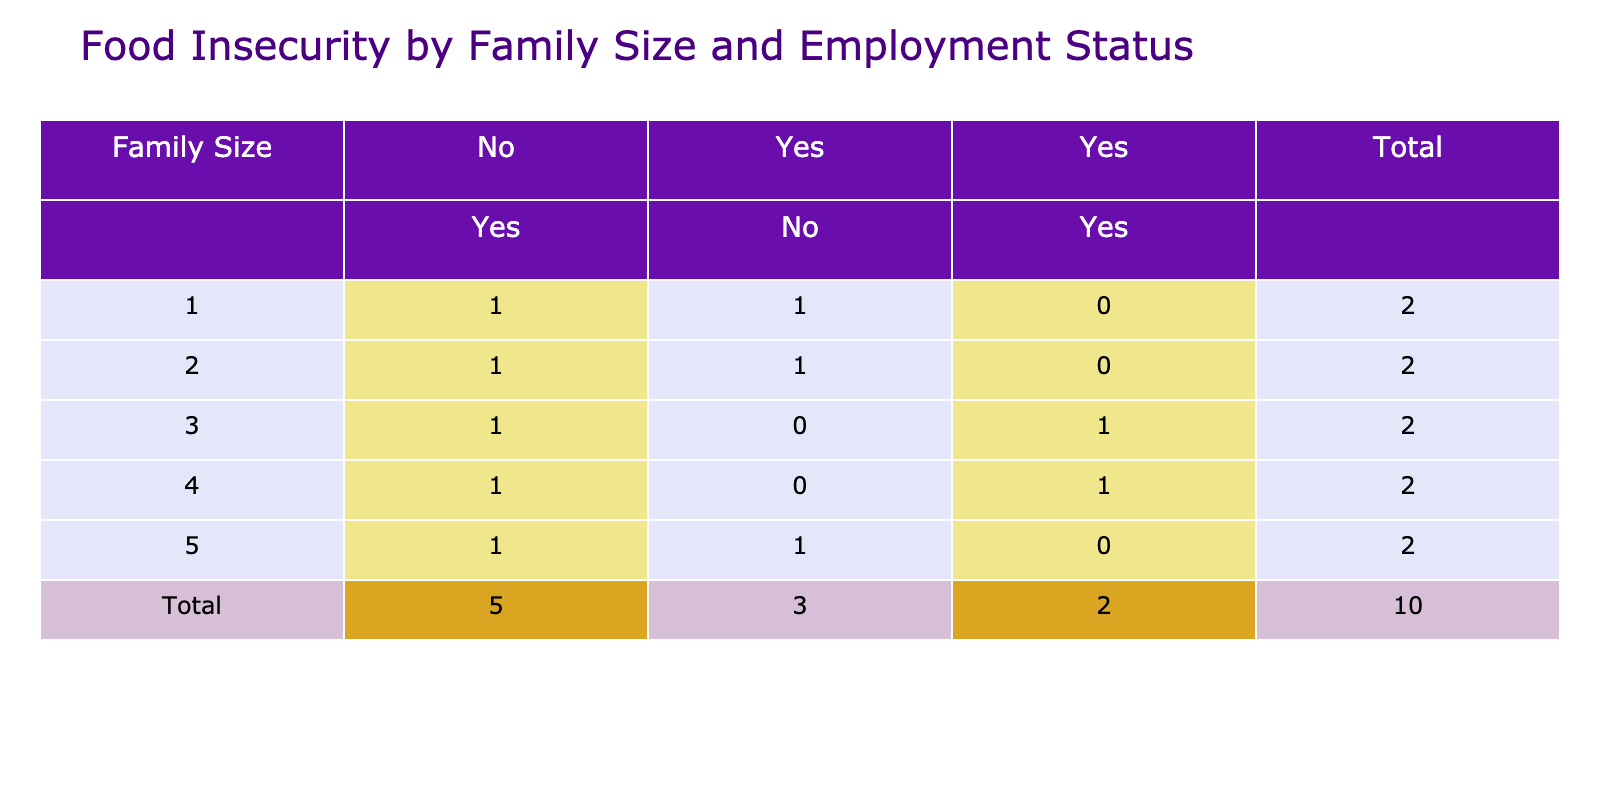What is the total number of food insecure individuals in families of size 1? In the table, for family size 1, there is 1 individual who is employed but food insecure and 1 individual who is unemployed and food insecure. Therefore, the total number of food insecure individuals in families of size 1 is 1 + 1 = 2.
Answer: 2 What proportion of employed individuals are food insecure in families of size 3? For family size 3, there are 2 employed individuals (1 full-time and 1 part-time), and both of them are food insecure. Therefore, the proportion of employed individuals who are food insecure is 2 out of 2, which simplifies to 100%.
Answer: 100% Is there any food insecurity reported among employed individuals in families of size 2? In family size 2, there is 1 employed individual who is food insecure (full-time). Thus, there is food insecurity among employed individuals in families of size 2.
Answer: Yes How many total individuals are food insecure across all family sizes? By examining all family sizes, the number of food insecure individuals is calculated as follows: For family size 1, there are 2; family size 2 has 2; family sizes 3 and 4 have 2 each; and family size 5 has 2. Summing these gives a total of 2 + 2 + 2 + 2 + 2 = 10.
Answer: 10 What is the difference in food insecurity between families of size 4 and families of size 5? For families of size 4, there are 2 food insecure individuals, while for families of size 5, there are also 2 food insecure individuals. The difference in food insecurity is 2 - 2 = 0.
Answer: 0 How many total food insecure individuals are unemployed across all family sizes? In the table, the number of unemployed food insecure individuals is: 1 each for family sizes 1, 2, 3, 4, and 5; thus, the total is 1 + 1 + 1 + 1 + 1 = 5.
Answer: 5 Is it true that families of size 2 report no food insecurity among employed individuals? For family size 2, though there are employed individuals, one of them is food insecure (full-time), so it is not true that families of size 2 report no food insecurity among employed individuals.
Answer: No What is the average number of food insecure individuals for families with size 3? In families of size 3, there are 2 food insecure individuals. As only one family falls into this category, the average remains 2/1 = 2.
Answer: 2 